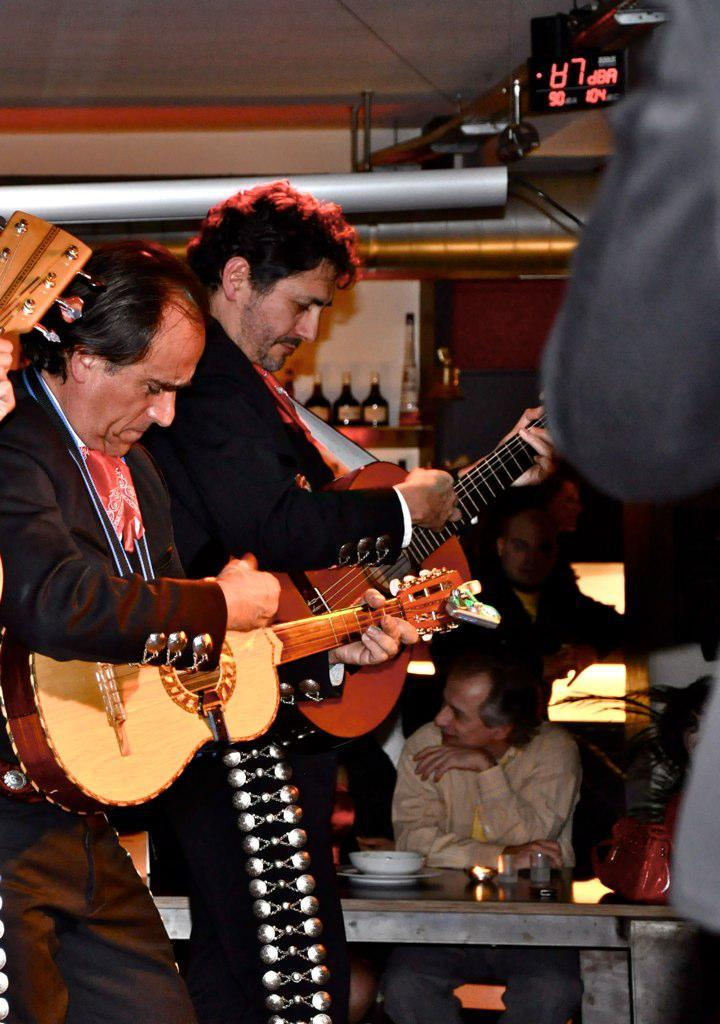How many people are in the image? There are two men in the image. What are the two men doing in the image? The two men are playing guitar. Can you describe the background of the image? There is a man sitting on a table in the background. What type of mint can be seen growing near the sea in the image? There is no sea or mint present in the image; it features two men playing guitar and a man sitting on a table in the background. 